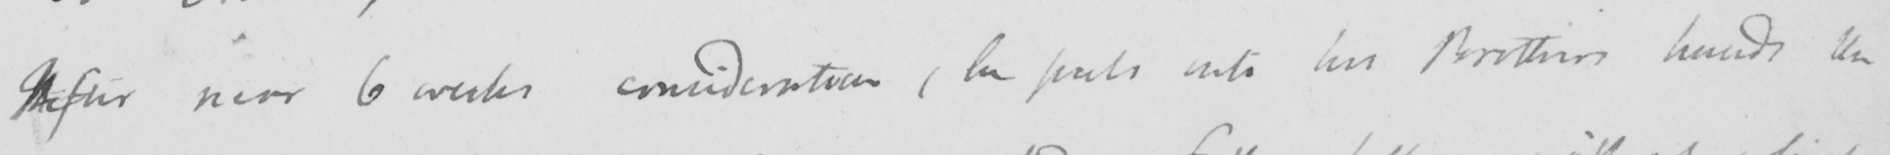Please provide the text content of this handwritten line. After near 6 weeks consideration , he puts into his Brother ' s hands the 